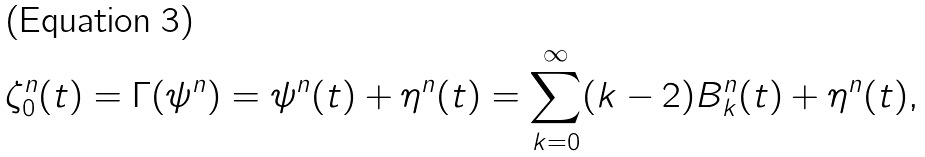Convert formula to latex. <formula><loc_0><loc_0><loc_500><loc_500>\zeta ^ { n } _ { 0 } ( t ) = \Gamma ( \psi ^ { n } ) = \psi ^ { n } ( t ) + \eta ^ { n } ( t ) = \sum _ { k = 0 } ^ { \infty } ( k - 2 ) B _ { k } ^ { n } ( t ) + \eta ^ { n } ( t ) ,</formula> 